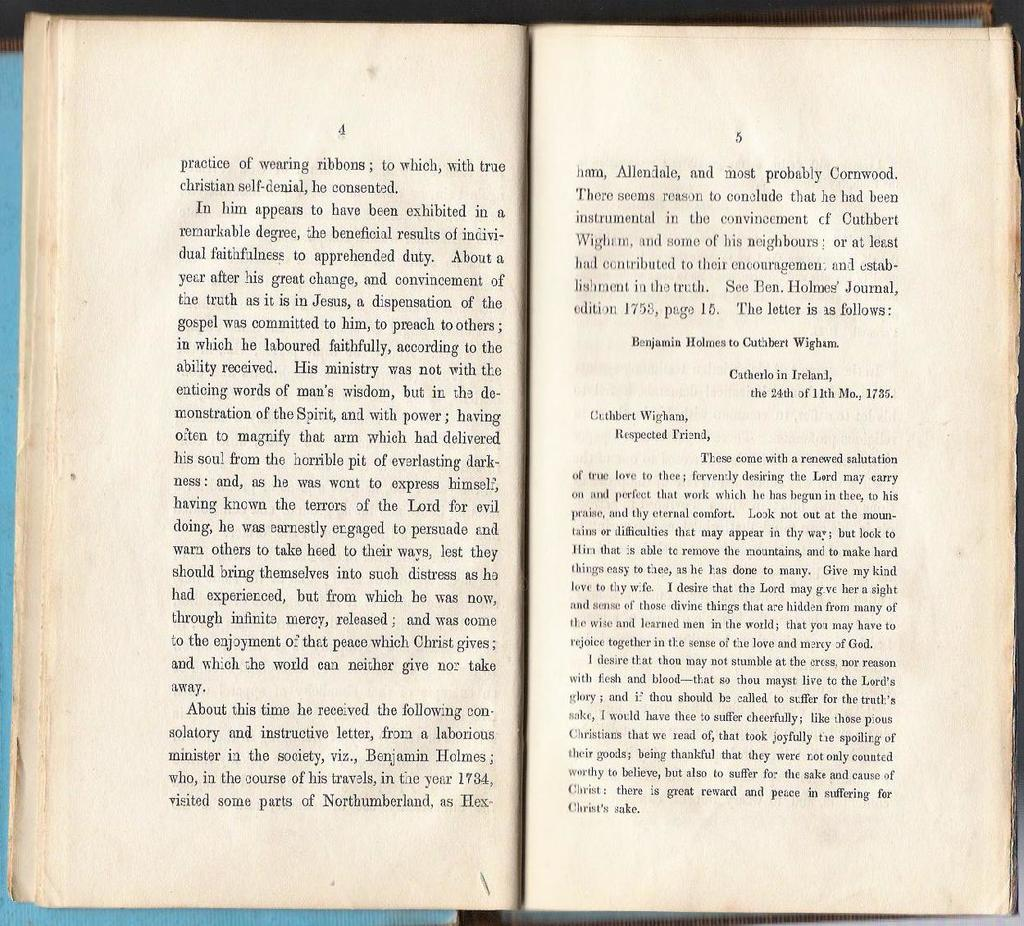<image>
Render a clear and concise summary of the photo. Page 4 and 5 of a book that starts out with "the practice of wearing ribbons". 